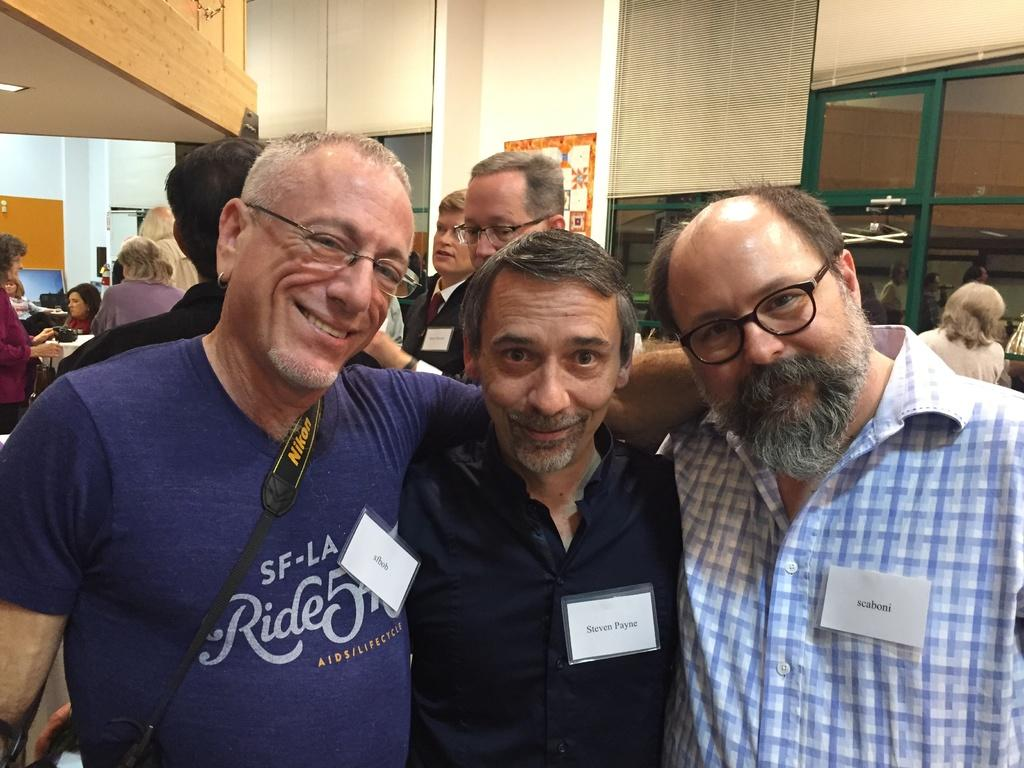How many persons are in the image? There are three persons in the image. What can be observed about the attire of the persons? The persons are wearing different color dresses. What are the persons wearing on their dresses? The persons are wearing badges. What is the facial expression of the persons? The persons are smiling. What position are the persons in? The persons are standing. Can you describe the background of the image? There are other persons in the background of the image, and there is a white wall. What type of bells can be heard ringing in the image? There are no bells or sounds present in the image, as it is a still photograph. 